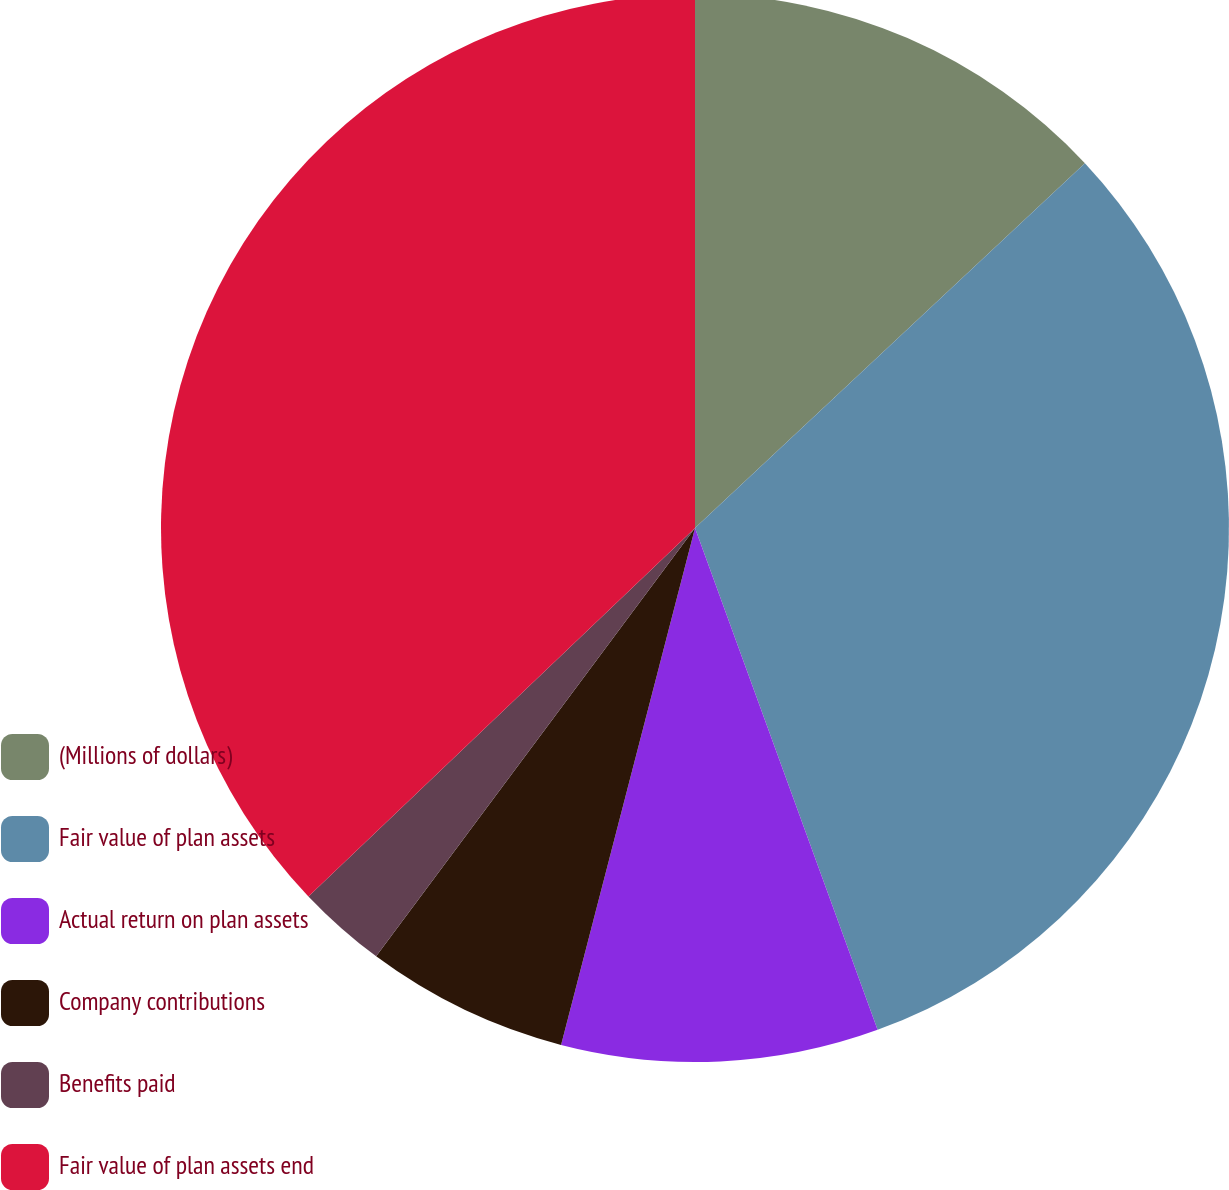Convert chart. <chart><loc_0><loc_0><loc_500><loc_500><pie_chart><fcel>(Millions of dollars)<fcel>Fair value of plan assets<fcel>Actual return on plan assets<fcel>Company contributions<fcel>Benefits paid<fcel>Fair value of plan assets end<nl><fcel>13.03%<fcel>31.42%<fcel>9.59%<fcel>6.15%<fcel>2.7%<fcel>37.12%<nl></chart> 